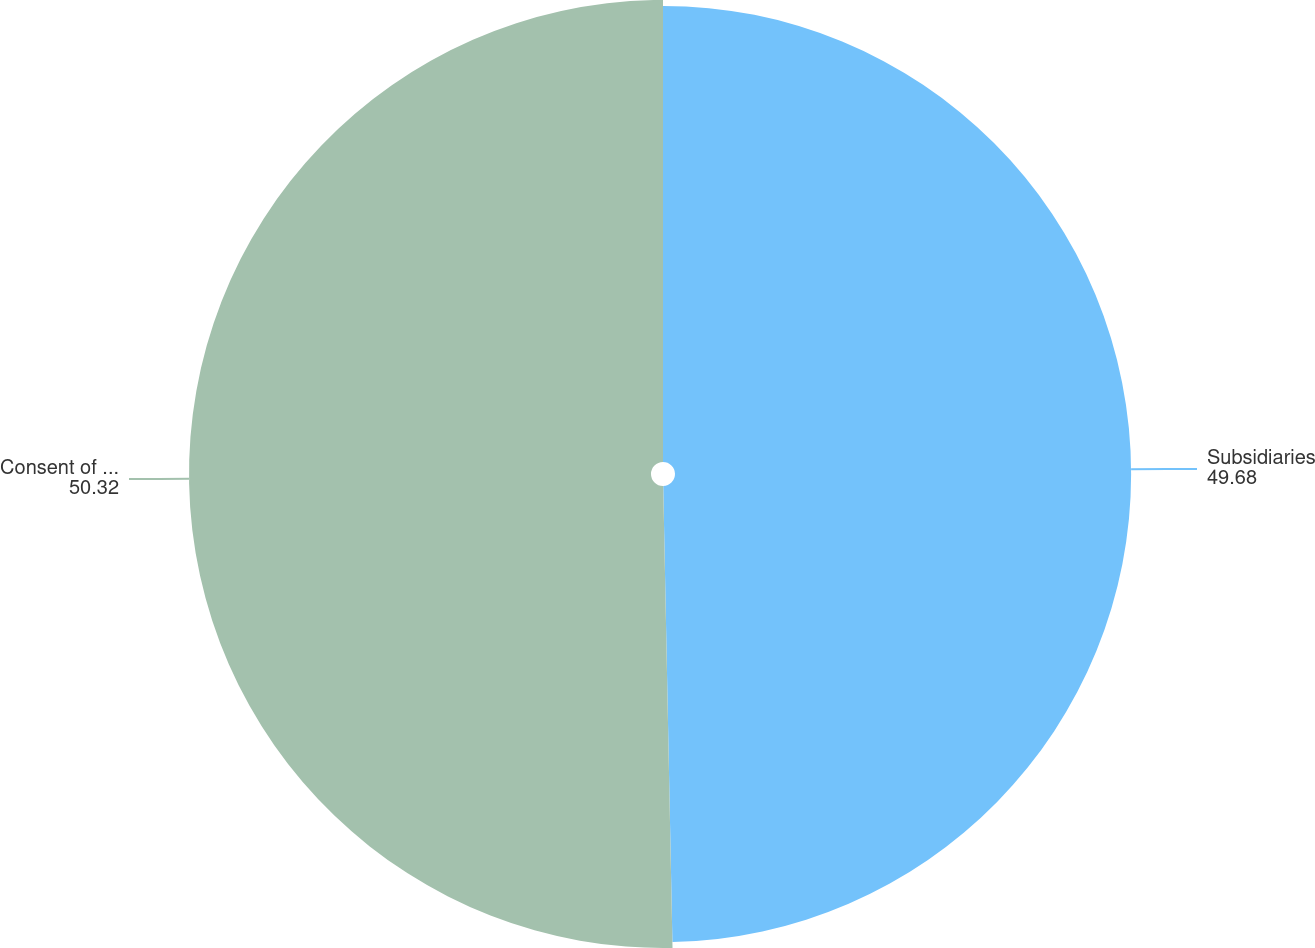Convert chart to OTSL. <chart><loc_0><loc_0><loc_500><loc_500><pie_chart><fcel>Subsidiaries<fcel>Consent of Independent<nl><fcel>49.68%<fcel>50.32%<nl></chart> 